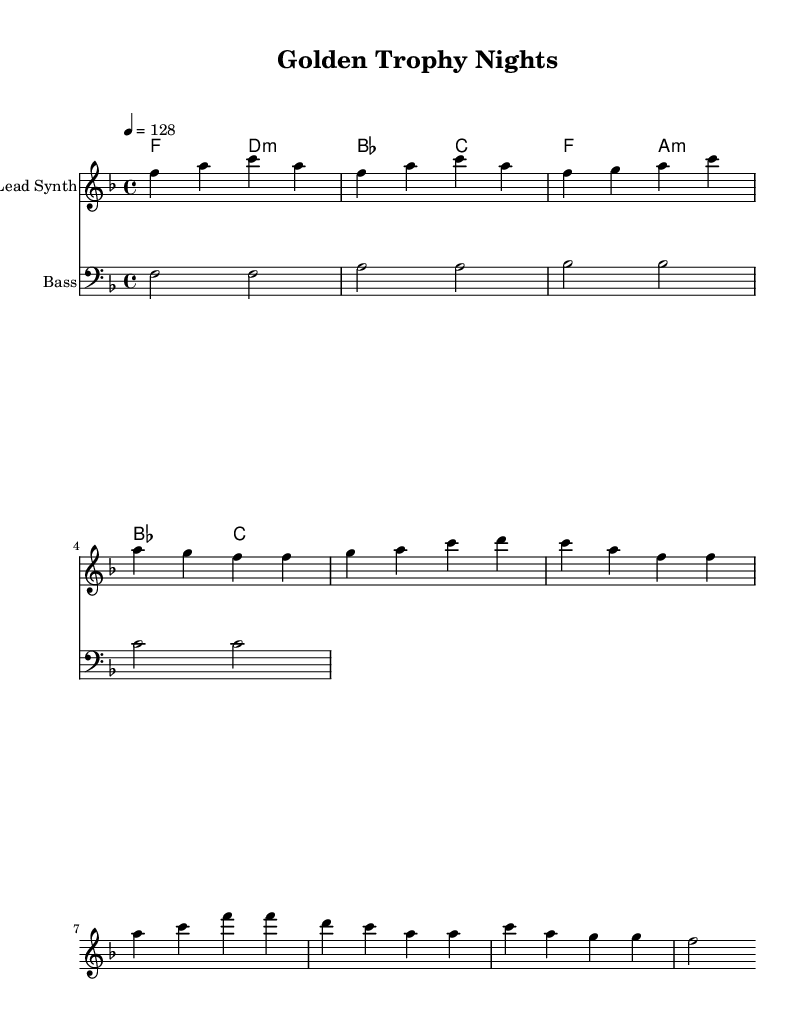What is the key signature of this music? The key signature at the beginning of the piece indicates F major, which has one flat note (B flat). This is determined by looking at the key signature indicated in the music notation.
Answer: F major What is the time signature of this music? The time signature is indicated at the beginning as 4/4, meaning each measure consists of four beats and a quarter note gets one beat. This can be seen at the start of the sheet music under the key signature.
Answer: 4/4 What is the tempo marking of this music? The tempo marking specifies the speed as '4 = 128', meaning the quarter note receives 128 beats per minute. This is found after the time signature in the score.
Answer: 128 How many measures are in the chorus section? To find the number of measures in the chorus section, I can count the distinct groupings of notes following the verse section in the lead synth part. In this case, the chorus consists of four measures.
Answer: 4 What instruments are indicated in this score? The score includes two instruments: "Lead Synth" for the main melody and "Bass" for the supporting bass line. Their names appear above their respective staves in the score.
Answer: Lead Synth and Bass What is the chord progression used in the verse? The chord progression listed under the verse section contains four chords: F, D minor, B flat, and C. This sequence appears in the chord names section beneath the melody stave.
Answer: F, D minor, B flat, C What type of music is represented in this sheet music? The structured composition, upbeat tempo, and synthesizer parts indicate that this piece falls under the House genre, focusing on celebratory themes. This is inferred from the musical style commonly associated with house music and the thematic title "Golden Trophy Nights."
Answer: House 